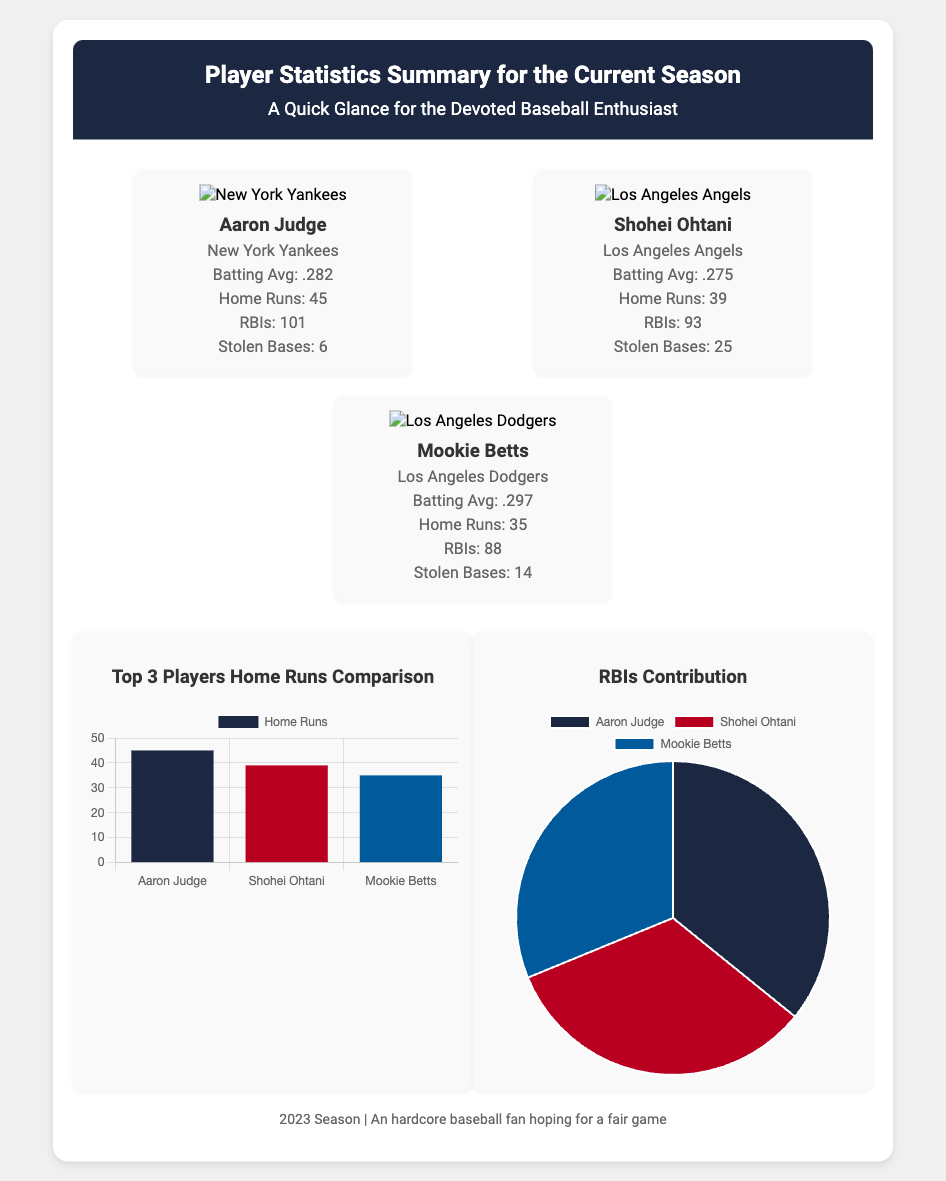What is Aaron Judge's batting average? Aaron Judge's batting average is stated in the document, which is .282.
Answer: .282 How many home runs did Shohei Ohtani hit? The document provides Shohei Ohtani's home runs total, which is 39.
Answer: 39 Which team does Mookie Betts play for? The team associated with Mookie Betts is indicated in the document as the Los Angeles Dodgers.
Answer: Los Angeles Dodgers What is the total number of RBIs for Aaron Judge? The document specifies the total RBIs for Aaron Judge, which is 101.
Answer: 101 Who has the highest number of stolen bases among the players listed? The document lists stolen bases for each player, with Shohei Ohtani having the highest at 25.
Answer: 25 What color is used in the background of the header? The background color of the header section is noted in the document as #1C2841.
Answer: #1C2841 What type of chart shows home runs comparison? The document describes a bar graph used for comparing home runs among the players.
Answer: Bar graph How many players' statistics are summarized in the document? The summary includes statistics for three players, as indicated in the player statistics section.
Answer: Three What logo is present at the top of Aaron Judge's section? The logo at the top of Aaron Judge's section is associated with the New York Yankees.
Answer: New York Yankees 